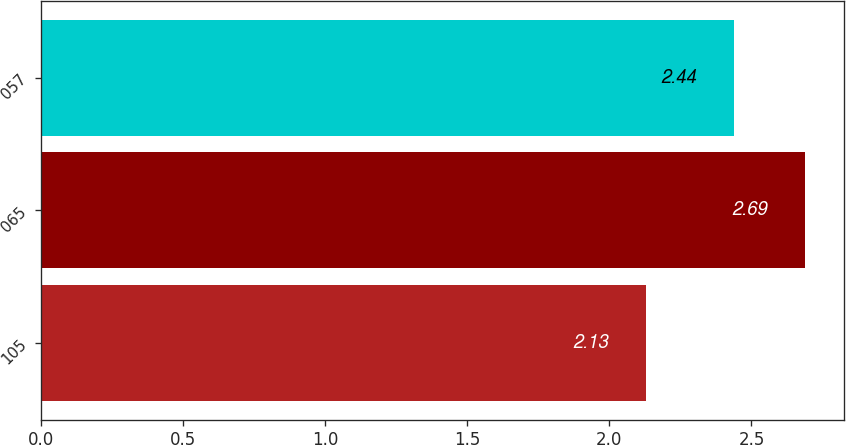<chart> <loc_0><loc_0><loc_500><loc_500><bar_chart><fcel>105<fcel>065<fcel>057<nl><fcel>2.13<fcel>2.69<fcel>2.44<nl></chart> 